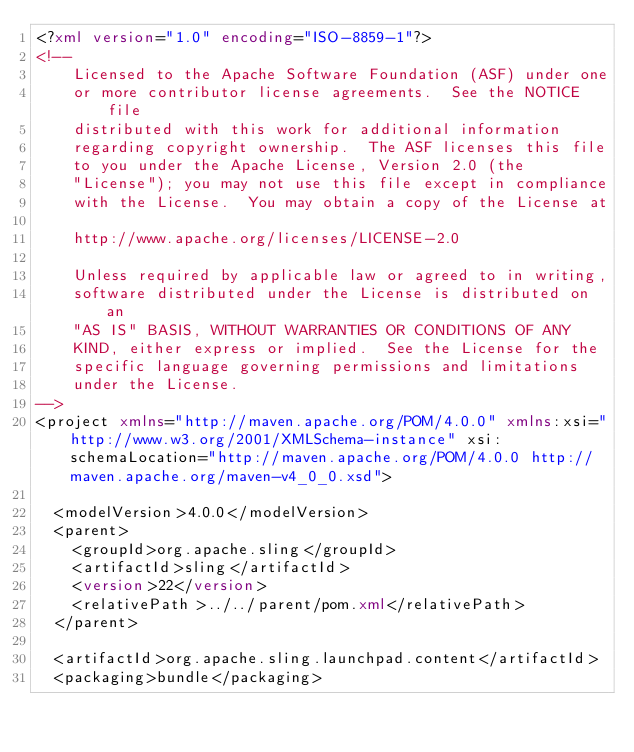<code> <loc_0><loc_0><loc_500><loc_500><_XML_><?xml version="1.0" encoding="ISO-8859-1"?>
<!--
    Licensed to the Apache Software Foundation (ASF) under one
    or more contributor license agreements.  See the NOTICE file
    distributed with this work for additional information
    regarding copyright ownership.  The ASF licenses this file
    to you under the Apache License, Version 2.0 (the
    "License"); you may not use this file except in compliance
    with the License.  You may obtain a copy of the License at
    
    http://www.apache.org/licenses/LICENSE-2.0
    
    Unless required by applicable law or agreed to in writing,
    software distributed under the License is distributed on an
    "AS IS" BASIS, WITHOUT WARRANTIES OR CONDITIONS OF ANY
    KIND, either express or implied.  See the License for the
    specific language governing permissions and limitations
    under the License.
-->
<project xmlns="http://maven.apache.org/POM/4.0.0" xmlns:xsi="http://www.w3.org/2001/XMLSchema-instance" xsi:schemaLocation="http://maven.apache.org/POM/4.0.0 http://maven.apache.org/maven-v4_0_0.xsd">

  <modelVersion>4.0.0</modelVersion>
  <parent>
    <groupId>org.apache.sling</groupId>
    <artifactId>sling</artifactId>
    <version>22</version>
    <relativePath>../../parent/pom.xml</relativePath>
  </parent>

  <artifactId>org.apache.sling.launchpad.content</artifactId>
  <packaging>bundle</packaging></code> 